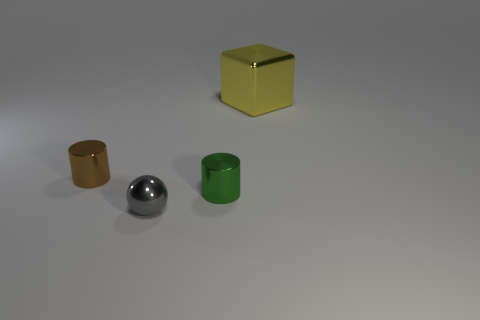Is the shape of the small brown shiny thing behind the tiny green shiny cylinder the same as the metallic thing right of the tiny green thing?
Your answer should be compact. No. How many green metallic things are in front of the tiny gray ball?
Give a very brief answer. 0. There is a tiny metal thing behind the tiny green shiny cylinder; what color is it?
Provide a short and direct response. Brown. What color is the other tiny metallic thing that is the same shape as the green object?
Make the answer very short. Brown. Are there any other things that have the same color as the large thing?
Offer a very short reply. No. Is the number of large blue cylinders greater than the number of brown metallic cylinders?
Give a very brief answer. No. Do the cube and the small brown cylinder have the same material?
Your response must be concise. Yes. How many cubes are the same material as the gray sphere?
Your answer should be very brief. 1. Does the brown metal cylinder have the same size as the green object that is behind the metallic sphere?
Ensure brevity in your answer.  Yes. The metallic object that is on the right side of the sphere and behind the small green cylinder is what color?
Keep it short and to the point. Yellow. 